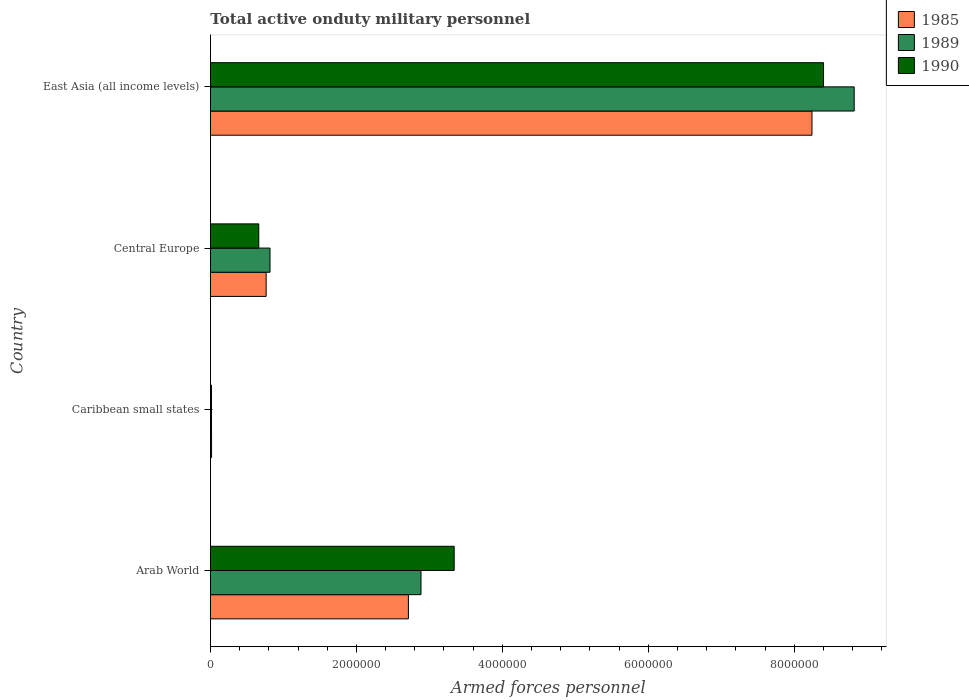How many different coloured bars are there?
Ensure brevity in your answer.  3. How many groups of bars are there?
Give a very brief answer. 4. Are the number of bars on each tick of the Y-axis equal?
Offer a very short reply. Yes. How many bars are there on the 1st tick from the bottom?
Provide a short and direct response. 3. What is the label of the 1st group of bars from the top?
Provide a short and direct response. East Asia (all income levels). In how many cases, is the number of bars for a given country not equal to the number of legend labels?
Provide a short and direct response. 0. What is the number of armed forces personnel in 1990 in East Asia (all income levels)?
Make the answer very short. 8.40e+06. Across all countries, what is the maximum number of armed forces personnel in 1985?
Provide a short and direct response. 8.24e+06. Across all countries, what is the minimum number of armed forces personnel in 1990?
Provide a short and direct response. 1.40e+04. In which country was the number of armed forces personnel in 1989 maximum?
Keep it short and to the point. East Asia (all income levels). In which country was the number of armed forces personnel in 1990 minimum?
Provide a short and direct response. Caribbean small states. What is the total number of armed forces personnel in 1990 in the graph?
Give a very brief answer. 1.24e+07. What is the difference between the number of armed forces personnel in 1989 in Arab World and that in East Asia (all income levels)?
Your response must be concise. -5.94e+06. What is the difference between the number of armed forces personnel in 1985 in East Asia (all income levels) and the number of armed forces personnel in 1989 in Central Europe?
Ensure brevity in your answer.  7.43e+06. What is the average number of armed forces personnel in 1985 per country?
Ensure brevity in your answer.  2.93e+06. What is the difference between the number of armed forces personnel in 1989 and number of armed forces personnel in 1985 in Caribbean small states?
Provide a succinct answer. -1000. What is the ratio of the number of armed forces personnel in 1989 in Caribbean small states to that in Central Europe?
Your answer should be compact. 0.02. Is the difference between the number of armed forces personnel in 1989 in Arab World and Caribbean small states greater than the difference between the number of armed forces personnel in 1985 in Arab World and Caribbean small states?
Provide a short and direct response. Yes. What is the difference between the highest and the second highest number of armed forces personnel in 1989?
Offer a very short reply. 5.94e+06. What is the difference between the highest and the lowest number of armed forces personnel in 1985?
Keep it short and to the point. 8.23e+06. In how many countries, is the number of armed forces personnel in 1989 greater than the average number of armed forces personnel in 1989 taken over all countries?
Keep it short and to the point. 1. Is the sum of the number of armed forces personnel in 1989 in Arab World and Central Europe greater than the maximum number of armed forces personnel in 1985 across all countries?
Provide a short and direct response. No. What does the 2nd bar from the bottom in Caribbean small states represents?
Provide a short and direct response. 1989. Is it the case that in every country, the sum of the number of armed forces personnel in 1990 and number of armed forces personnel in 1989 is greater than the number of armed forces personnel in 1985?
Make the answer very short. Yes. How many countries are there in the graph?
Keep it short and to the point. 4. Are the values on the major ticks of X-axis written in scientific E-notation?
Your response must be concise. No. Does the graph contain any zero values?
Provide a succinct answer. No. Does the graph contain grids?
Your answer should be very brief. No. Where does the legend appear in the graph?
Give a very brief answer. Top right. How many legend labels are there?
Your answer should be very brief. 3. How are the legend labels stacked?
Your answer should be very brief. Vertical. What is the title of the graph?
Your answer should be very brief. Total active onduty military personnel. Does "1965" appear as one of the legend labels in the graph?
Make the answer very short. No. What is the label or title of the X-axis?
Provide a succinct answer. Armed forces personnel. What is the Armed forces personnel of 1985 in Arab World?
Give a very brief answer. 2.71e+06. What is the Armed forces personnel of 1989 in Arab World?
Your answer should be very brief. 2.88e+06. What is the Armed forces personnel of 1990 in Arab World?
Offer a terse response. 3.34e+06. What is the Armed forces personnel of 1985 in Caribbean small states?
Provide a succinct answer. 1.50e+04. What is the Armed forces personnel of 1989 in Caribbean small states?
Your response must be concise. 1.40e+04. What is the Armed forces personnel in 1990 in Caribbean small states?
Your answer should be very brief. 1.40e+04. What is the Armed forces personnel in 1985 in Central Europe?
Ensure brevity in your answer.  7.63e+05. What is the Armed forces personnel in 1989 in Central Europe?
Your answer should be compact. 8.16e+05. What is the Armed forces personnel of 1990 in Central Europe?
Provide a succinct answer. 6.62e+05. What is the Armed forces personnel of 1985 in East Asia (all income levels)?
Your answer should be very brief. 8.24e+06. What is the Armed forces personnel in 1989 in East Asia (all income levels)?
Your answer should be very brief. 8.82e+06. What is the Armed forces personnel in 1990 in East Asia (all income levels)?
Your answer should be very brief. 8.40e+06. Across all countries, what is the maximum Armed forces personnel in 1985?
Make the answer very short. 8.24e+06. Across all countries, what is the maximum Armed forces personnel of 1989?
Your response must be concise. 8.82e+06. Across all countries, what is the maximum Armed forces personnel in 1990?
Ensure brevity in your answer.  8.40e+06. Across all countries, what is the minimum Armed forces personnel of 1985?
Give a very brief answer. 1.50e+04. Across all countries, what is the minimum Armed forces personnel of 1989?
Your answer should be compact. 1.40e+04. Across all countries, what is the minimum Armed forces personnel of 1990?
Offer a terse response. 1.40e+04. What is the total Armed forces personnel of 1985 in the graph?
Provide a short and direct response. 1.17e+07. What is the total Armed forces personnel in 1989 in the graph?
Provide a short and direct response. 1.25e+07. What is the total Armed forces personnel in 1990 in the graph?
Give a very brief answer. 1.24e+07. What is the difference between the Armed forces personnel in 1985 in Arab World and that in Caribbean small states?
Provide a short and direct response. 2.70e+06. What is the difference between the Armed forces personnel in 1989 in Arab World and that in Caribbean small states?
Your answer should be compact. 2.87e+06. What is the difference between the Armed forces personnel of 1990 in Arab World and that in Caribbean small states?
Keep it short and to the point. 3.33e+06. What is the difference between the Armed forces personnel in 1985 in Arab World and that in Central Europe?
Provide a short and direct response. 1.95e+06. What is the difference between the Armed forces personnel in 1989 in Arab World and that in Central Europe?
Give a very brief answer. 2.07e+06. What is the difference between the Armed forces personnel of 1990 in Arab World and that in Central Europe?
Offer a terse response. 2.68e+06. What is the difference between the Armed forces personnel of 1985 in Arab World and that in East Asia (all income levels)?
Your response must be concise. -5.53e+06. What is the difference between the Armed forces personnel of 1989 in Arab World and that in East Asia (all income levels)?
Keep it short and to the point. -5.94e+06. What is the difference between the Armed forces personnel in 1990 in Arab World and that in East Asia (all income levels)?
Your answer should be very brief. -5.06e+06. What is the difference between the Armed forces personnel in 1985 in Caribbean small states and that in Central Europe?
Offer a terse response. -7.48e+05. What is the difference between the Armed forces personnel of 1989 in Caribbean small states and that in Central Europe?
Your response must be concise. -8.02e+05. What is the difference between the Armed forces personnel of 1990 in Caribbean small states and that in Central Europe?
Your response must be concise. -6.48e+05. What is the difference between the Armed forces personnel of 1985 in Caribbean small states and that in East Asia (all income levels)?
Provide a succinct answer. -8.23e+06. What is the difference between the Armed forces personnel of 1989 in Caribbean small states and that in East Asia (all income levels)?
Ensure brevity in your answer.  -8.81e+06. What is the difference between the Armed forces personnel in 1990 in Caribbean small states and that in East Asia (all income levels)?
Your answer should be very brief. -8.39e+06. What is the difference between the Armed forces personnel in 1985 in Central Europe and that in East Asia (all income levels)?
Offer a very short reply. -7.48e+06. What is the difference between the Armed forces personnel of 1989 in Central Europe and that in East Asia (all income levels)?
Offer a very short reply. -8.01e+06. What is the difference between the Armed forces personnel of 1990 in Central Europe and that in East Asia (all income levels)?
Your answer should be very brief. -7.74e+06. What is the difference between the Armed forces personnel of 1985 in Arab World and the Armed forces personnel of 1989 in Caribbean small states?
Provide a short and direct response. 2.70e+06. What is the difference between the Armed forces personnel in 1985 in Arab World and the Armed forces personnel in 1990 in Caribbean small states?
Your answer should be compact. 2.70e+06. What is the difference between the Armed forces personnel in 1989 in Arab World and the Armed forces personnel in 1990 in Caribbean small states?
Give a very brief answer. 2.87e+06. What is the difference between the Armed forces personnel in 1985 in Arab World and the Armed forces personnel in 1989 in Central Europe?
Provide a succinct answer. 1.90e+06. What is the difference between the Armed forces personnel of 1985 in Arab World and the Armed forces personnel of 1990 in Central Europe?
Provide a succinct answer. 2.05e+06. What is the difference between the Armed forces personnel in 1989 in Arab World and the Armed forces personnel in 1990 in Central Europe?
Your response must be concise. 2.22e+06. What is the difference between the Armed forces personnel of 1985 in Arab World and the Armed forces personnel of 1989 in East Asia (all income levels)?
Your response must be concise. -6.11e+06. What is the difference between the Armed forces personnel in 1985 in Arab World and the Armed forces personnel in 1990 in East Asia (all income levels)?
Provide a succinct answer. -5.69e+06. What is the difference between the Armed forces personnel in 1989 in Arab World and the Armed forces personnel in 1990 in East Asia (all income levels)?
Ensure brevity in your answer.  -5.52e+06. What is the difference between the Armed forces personnel in 1985 in Caribbean small states and the Armed forces personnel in 1989 in Central Europe?
Ensure brevity in your answer.  -8.01e+05. What is the difference between the Armed forces personnel of 1985 in Caribbean small states and the Armed forces personnel of 1990 in Central Europe?
Make the answer very short. -6.47e+05. What is the difference between the Armed forces personnel of 1989 in Caribbean small states and the Armed forces personnel of 1990 in Central Europe?
Make the answer very short. -6.48e+05. What is the difference between the Armed forces personnel of 1985 in Caribbean small states and the Armed forces personnel of 1989 in East Asia (all income levels)?
Provide a short and direct response. -8.81e+06. What is the difference between the Armed forces personnel in 1985 in Caribbean small states and the Armed forces personnel in 1990 in East Asia (all income levels)?
Provide a succinct answer. -8.39e+06. What is the difference between the Armed forces personnel of 1989 in Caribbean small states and the Armed forces personnel of 1990 in East Asia (all income levels)?
Offer a very short reply. -8.39e+06. What is the difference between the Armed forces personnel in 1985 in Central Europe and the Armed forces personnel in 1989 in East Asia (all income levels)?
Keep it short and to the point. -8.06e+06. What is the difference between the Armed forces personnel of 1985 in Central Europe and the Armed forces personnel of 1990 in East Asia (all income levels)?
Provide a short and direct response. -7.64e+06. What is the difference between the Armed forces personnel in 1989 in Central Europe and the Armed forces personnel in 1990 in East Asia (all income levels)?
Your answer should be very brief. -7.59e+06. What is the average Armed forces personnel in 1985 per country?
Offer a terse response. 2.93e+06. What is the average Armed forces personnel in 1989 per country?
Make the answer very short. 3.13e+06. What is the average Armed forces personnel in 1990 per country?
Make the answer very short. 3.10e+06. What is the difference between the Armed forces personnel of 1985 and Armed forces personnel of 1989 in Arab World?
Make the answer very short. -1.72e+05. What is the difference between the Armed forces personnel of 1985 and Armed forces personnel of 1990 in Arab World?
Your answer should be compact. -6.27e+05. What is the difference between the Armed forces personnel of 1989 and Armed forces personnel of 1990 in Arab World?
Your answer should be compact. -4.55e+05. What is the difference between the Armed forces personnel of 1985 and Armed forces personnel of 1989 in Caribbean small states?
Offer a terse response. 1000. What is the difference between the Armed forces personnel of 1985 and Armed forces personnel of 1989 in Central Europe?
Provide a short and direct response. -5.30e+04. What is the difference between the Armed forces personnel in 1985 and Armed forces personnel in 1990 in Central Europe?
Offer a terse response. 1.01e+05. What is the difference between the Armed forces personnel in 1989 and Armed forces personnel in 1990 in Central Europe?
Provide a short and direct response. 1.54e+05. What is the difference between the Armed forces personnel of 1985 and Armed forces personnel of 1989 in East Asia (all income levels)?
Provide a short and direct response. -5.78e+05. What is the difference between the Armed forces personnel in 1985 and Armed forces personnel in 1990 in East Asia (all income levels)?
Your answer should be very brief. -1.58e+05. What is the difference between the Armed forces personnel in 1989 and Armed forces personnel in 1990 in East Asia (all income levels)?
Your response must be concise. 4.20e+05. What is the ratio of the Armed forces personnel of 1985 in Arab World to that in Caribbean small states?
Offer a very short reply. 180.85. What is the ratio of the Armed forces personnel of 1989 in Arab World to that in Caribbean small states?
Give a very brief answer. 206.07. What is the ratio of the Armed forces personnel of 1990 in Arab World to that in Caribbean small states?
Give a very brief answer. 238.57. What is the ratio of the Armed forces personnel in 1985 in Arab World to that in Central Europe?
Make the answer very short. 3.56. What is the ratio of the Armed forces personnel in 1989 in Arab World to that in Central Europe?
Your answer should be very brief. 3.54. What is the ratio of the Armed forces personnel in 1990 in Arab World to that in Central Europe?
Provide a short and direct response. 5.05. What is the ratio of the Armed forces personnel in 1985 in Arab World to that in East Asia (all income levels)?
Offer a terse response. 0.33. What is the ratio of the Armed forces personnel of 1989 in Arab World to that in East Asia (all income levels)?
Offer a terse response. 0.33. What is the ratio of the Armed forces personnel in 1990 in Arab World to that in East Asia (all income levels)?
Keep it short and to the point. 0.4. What is the ratio of the Armed forces personnel of 1985 in Caribbean small states to that in Central Europe?
Provide a succinct answer. 0.02. What is the ratio of the Armed forces personnel in 1989 in Caribbean small states to that in Central Europe?
Make the answer very short. 0.02. What is the ratio of the Armed forces personnel in 1990 in Caribbean small states to that in Central Europe?
Give a very brief answer. 0.02. What is the ratio of the Armed forces personnel of 1985 in Caribbean small states to that in East Asia (all income levels)?
Make the answer very short. 0. What is the ratio of the Armed forces personnel in 1989 in Caribbean small states to that in East Asia (all income levels)?
Provide a short and direct response. 0. What is the ratio of the Armed forces personnel of 1990 in Caribbean small states to that in East Asia (all income levels)?
Keep it short and to the point. 0. What is the ratio of the Armed forces personnel in 1985 in Central Europe to that in East Asia (all income levels)?
Offer a very short reply. 0.09. What is the ratio of the Armed forces personnel in 1989 in Central Europe to that in East Asia (all income levels)?
Ensure brevity in your answer.  0.09. What is the ratio of the Armed forces personnel in 1990 in Central Europe to that in East Asia (all income levels)?
Your answer should be compact. 0.08. What is the difference between the highest and the second highest Armed forces personnel in 1985?
Your answer should be very brief. 5.53e+06. What is the difference between the highest and the second highest Armed forces personnel in 1989?
Your answer should be compact. 5.94e+06. What is the difference between the highest and the second highest Armed forces personnel of 1990?
Provide a succinct answer. 5.06e+06. What is the difference between the highest and the lowest Armed forces personnel in 1985?
Your answer should be very brief. 8.23e+06. What is the difference between the highest and the lowest Armed forces personnel of 1989?
Give a very brief answer. 8.81e+06. What is the difference between the highest and the lowest Armed forces personnel in 1990?
Provide a succinct answer. 8.39e+06. 